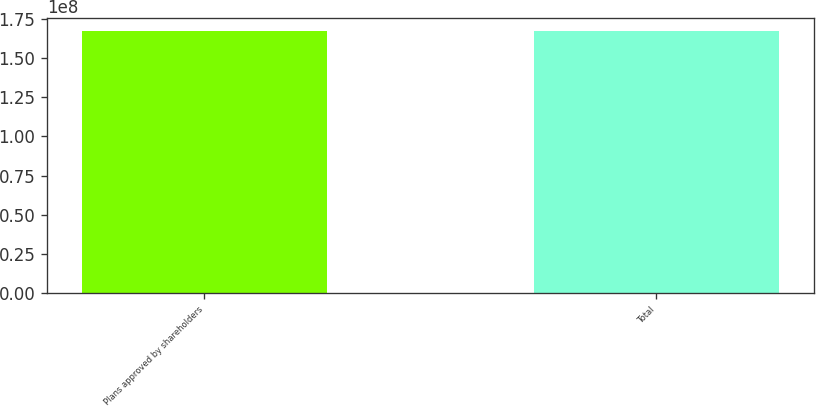<chart> <loc_0><loc_0><loc_500><loc_500><bar_chart><fcel>Plans approved by shareholders<fcel>Total<nl><fcel>1.67164e+08<fcel>1.67164e+08<nl></chart> 